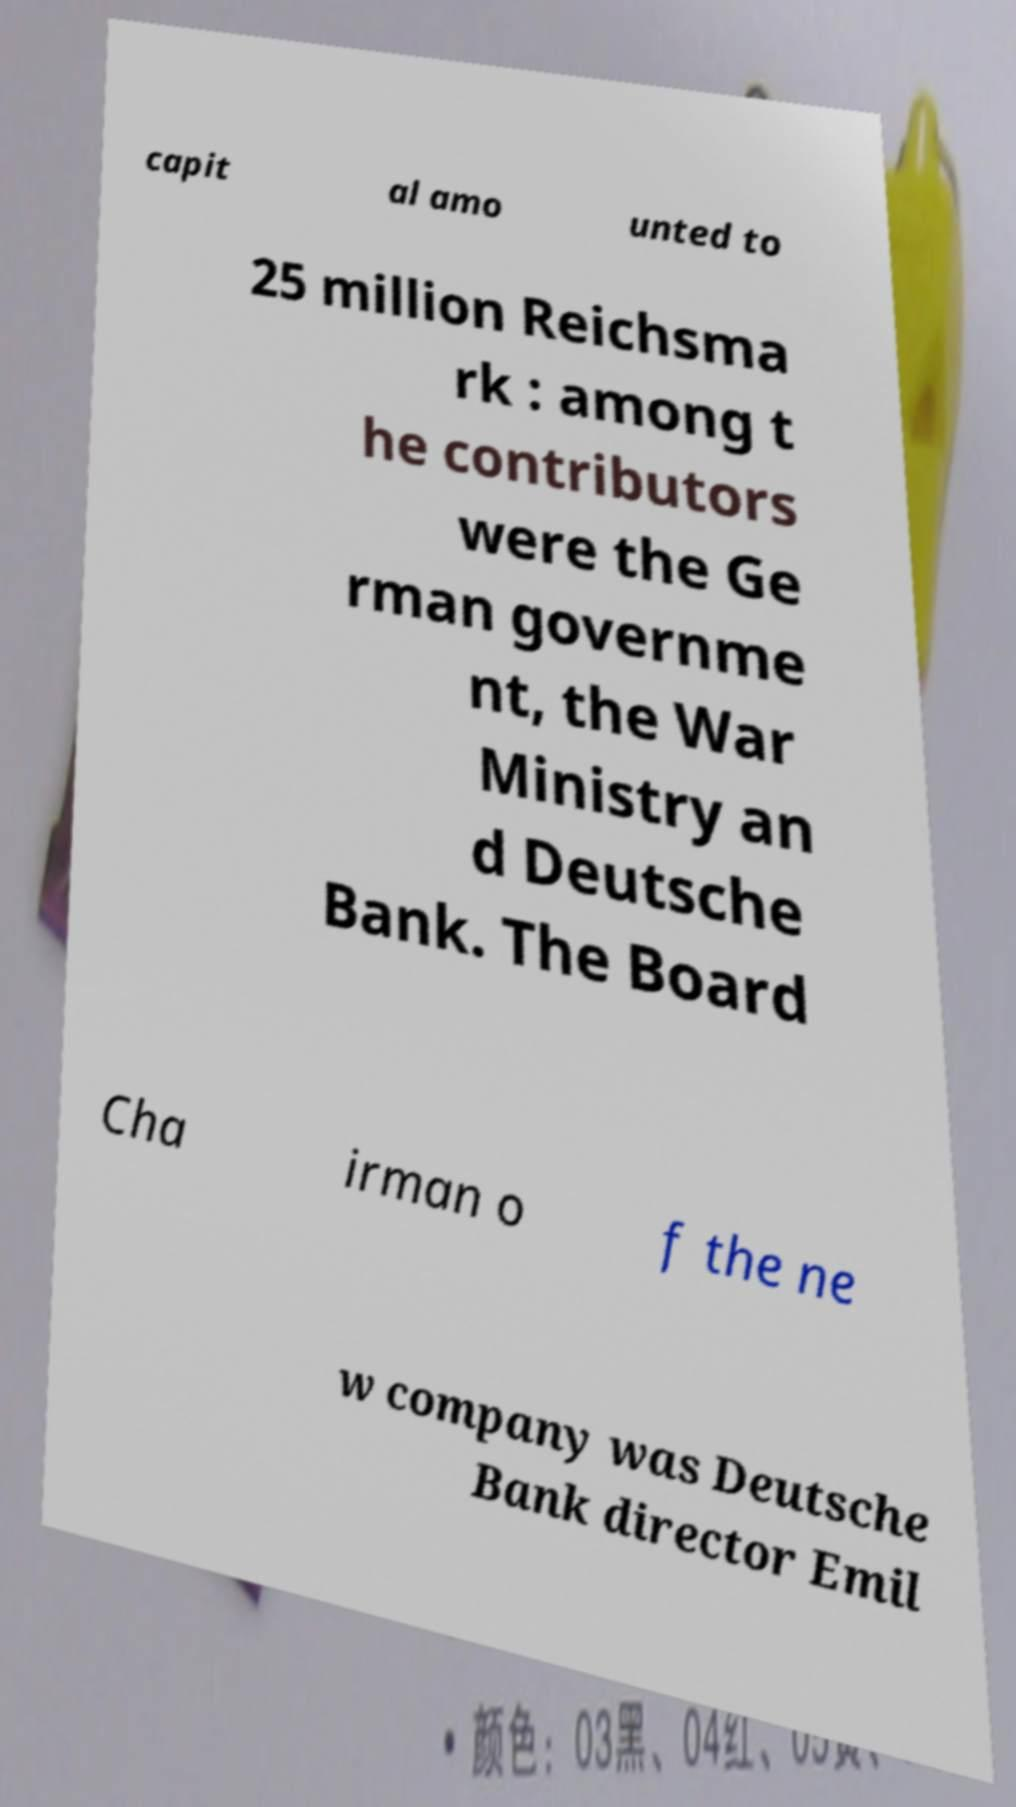Can you accurately transcribe the text from the provided image for me? capit al amo unted to 25 million Reichsma rk : among t he contributors were the Ge rman governme nt, the War Ministry an d Deutsche Bank. The Board Cha irman o f the ne w company was Deutsche Bank director Emil 